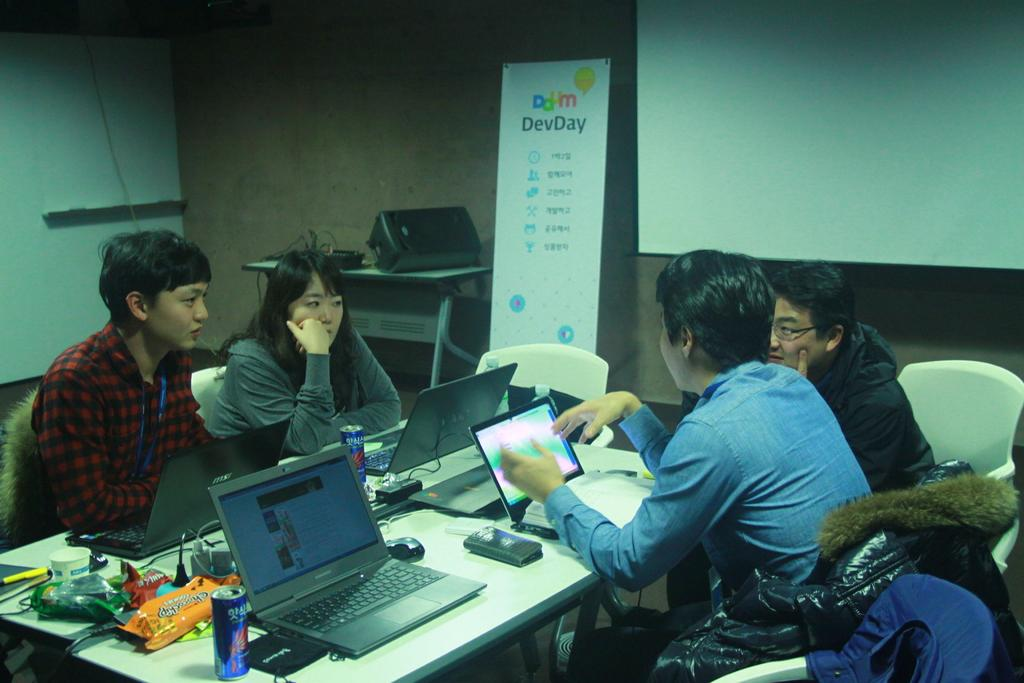<image>
Share a concise interpretation of the image provided. Four people having a meeting in a room with a sign that says "DevDay". 